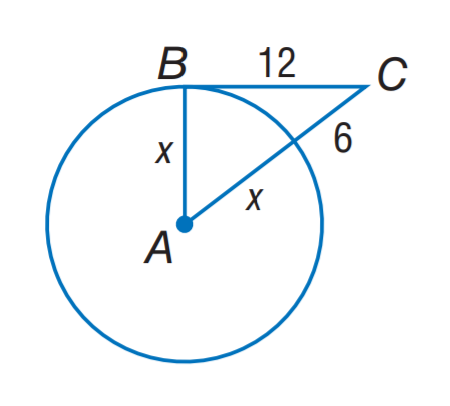Answer the mathemtical geometry problem and directly provide the correct option letter.
Question: The segment is tangent to the circle. Find x.
Choices: A: 6 B: 8 C: 9 D: 12 C 